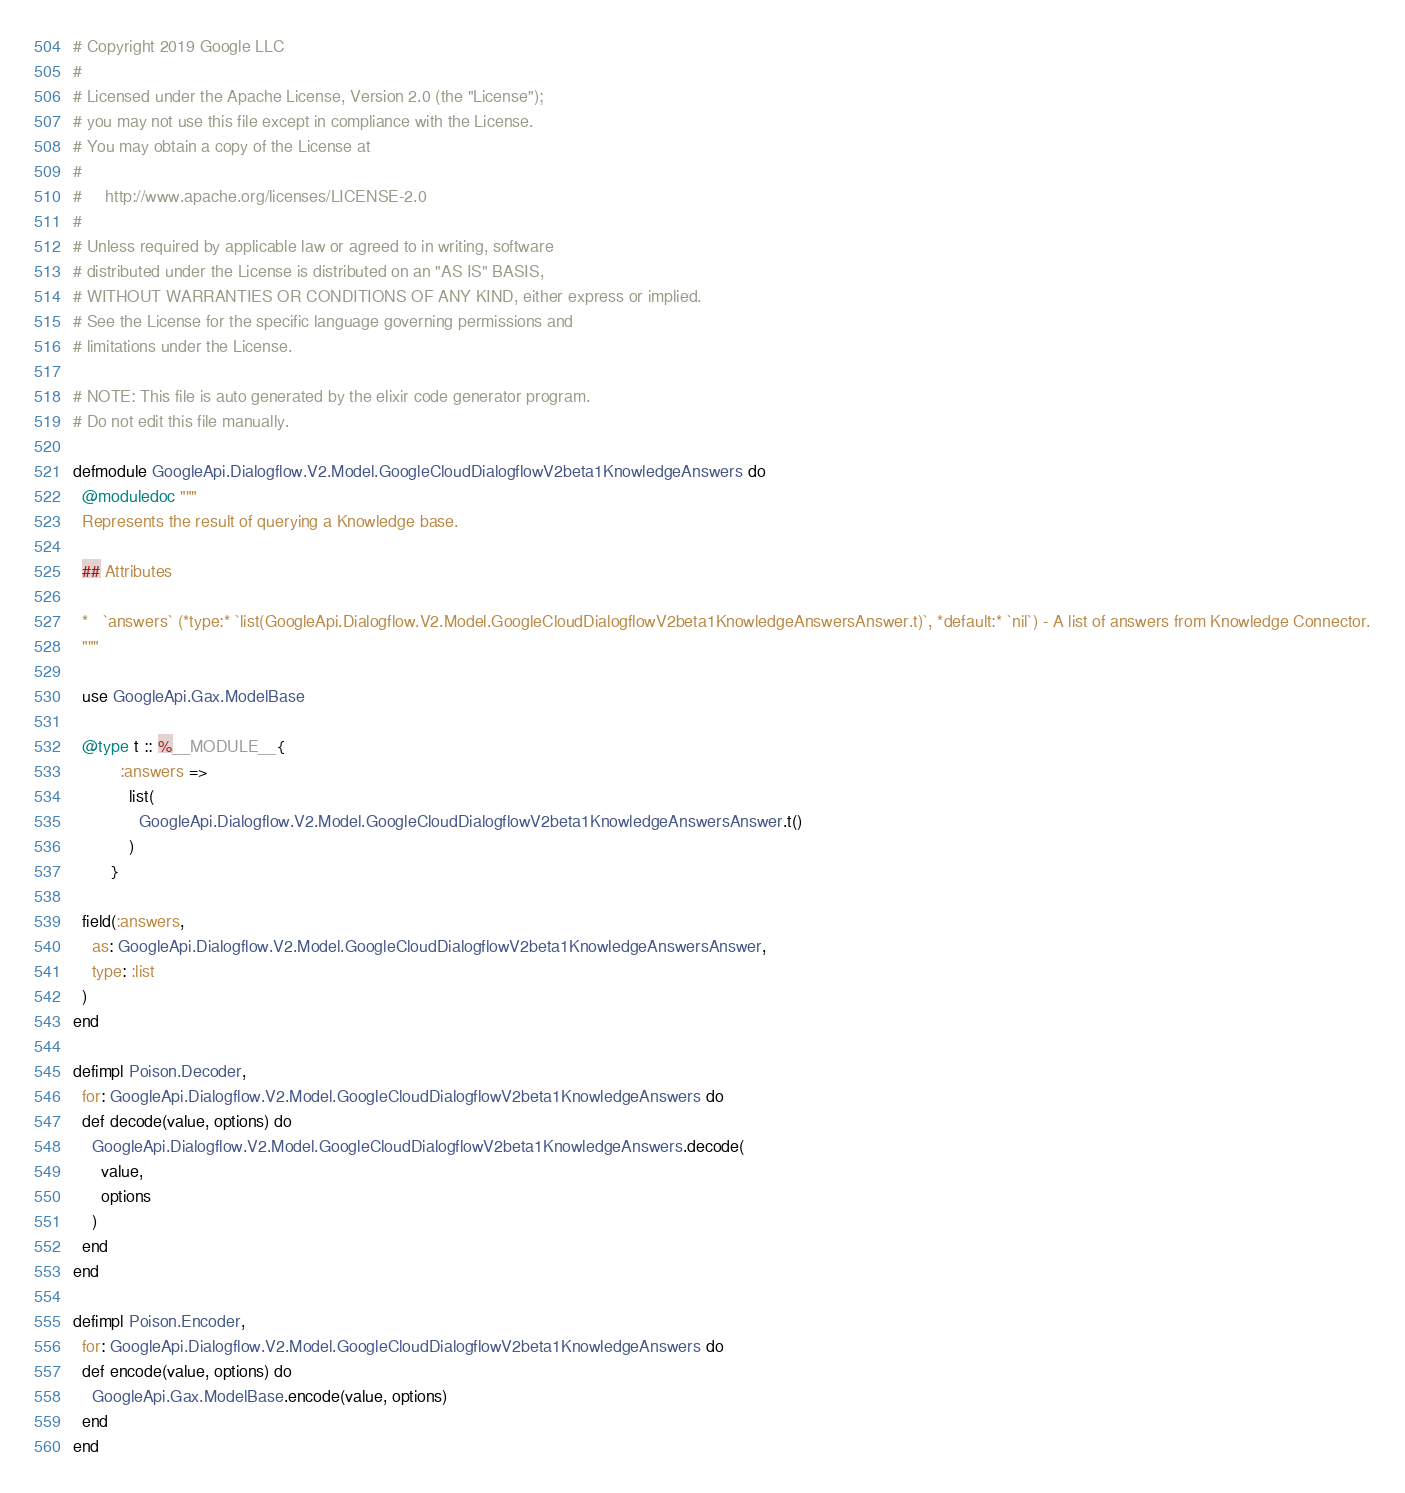<code> <loc_0><loc_0><loc_500><loc_500><_Elixir_># Copyright 2019 Google LLC
#
# Licensed under the Apache License, Version 2.0 (the "License");
# you may not use this file except in compliance with the License.
# You may obtain a copy of the License at
#
#     http://www.apache.org/licenses/LICENSE-2.0
#
# Unless required by applicable law or agreed to in writing, software
# distributed under the License is distributed on an "AS IS" BASIS,
# WITHOUT WARRANTIES OR CONDITIONS OF ANY KIND, either express or implied.
# See the License for the specific language governing permissions and
# limitations under the License.

# NOTE: This file is auto generated by the elixir code generator program.
# Do not edit this file manually.

defmodule GoogleApi.Dialogflow.V2.Model.GoogleCloudDialogflowV2beta1KnowledgeAnswers do
  @moduledoc """
  Represents the result of querying a Knowledge base.

  ## Attributes

  *   `answers` (*type:* `list(GoogleApi.Dialogflow.V2.Model.GoogleCloudDialogflowV2beta1KnowledgeAnswersAnswer.t)`, *default:* `nil`) - A list of answers from Knowledge Connector.
  """

  use GoogleApi.Gax.ModelBase

  @type t :: %__MODULE__{
          :answers =>
            list(
              GoogleApi.Dialogflow.V2.Model.GoogleCloudDialogflowV2beta1KnowledgeAnswersAnswer.t()
            )
        }

  field(:answers,
    as: GoogleApi.Dialogflow.V2.Model.GoogleCloudDialogflowV2beta1KnowledgeAnswersAnswer,
    type: :list
  )
end

defimpl Poison.Decoder,
  for: GoogleApi.Dialogflow.V2.Model.GoogleCloudDialogflowV2beta1KnowledgeAnswers do
  def decode(value, options) do
    GoogleApi.Dialogflow.V2.Model.GoogleCloudDialogflowV2beta1KnowledgeAnswers.decode(
      value,
      options
    )
  end
end

defimpl Poison.Encoder,
  for: GoogleApi.Dialogflow.V2.Model.GoogleCloudDialogflowV2beta1KnowledgeAnswers do
  def encode(value, options) do
    GoogleApi.Gax.ModelBase.encode(value, options)
  end
end
</code> 